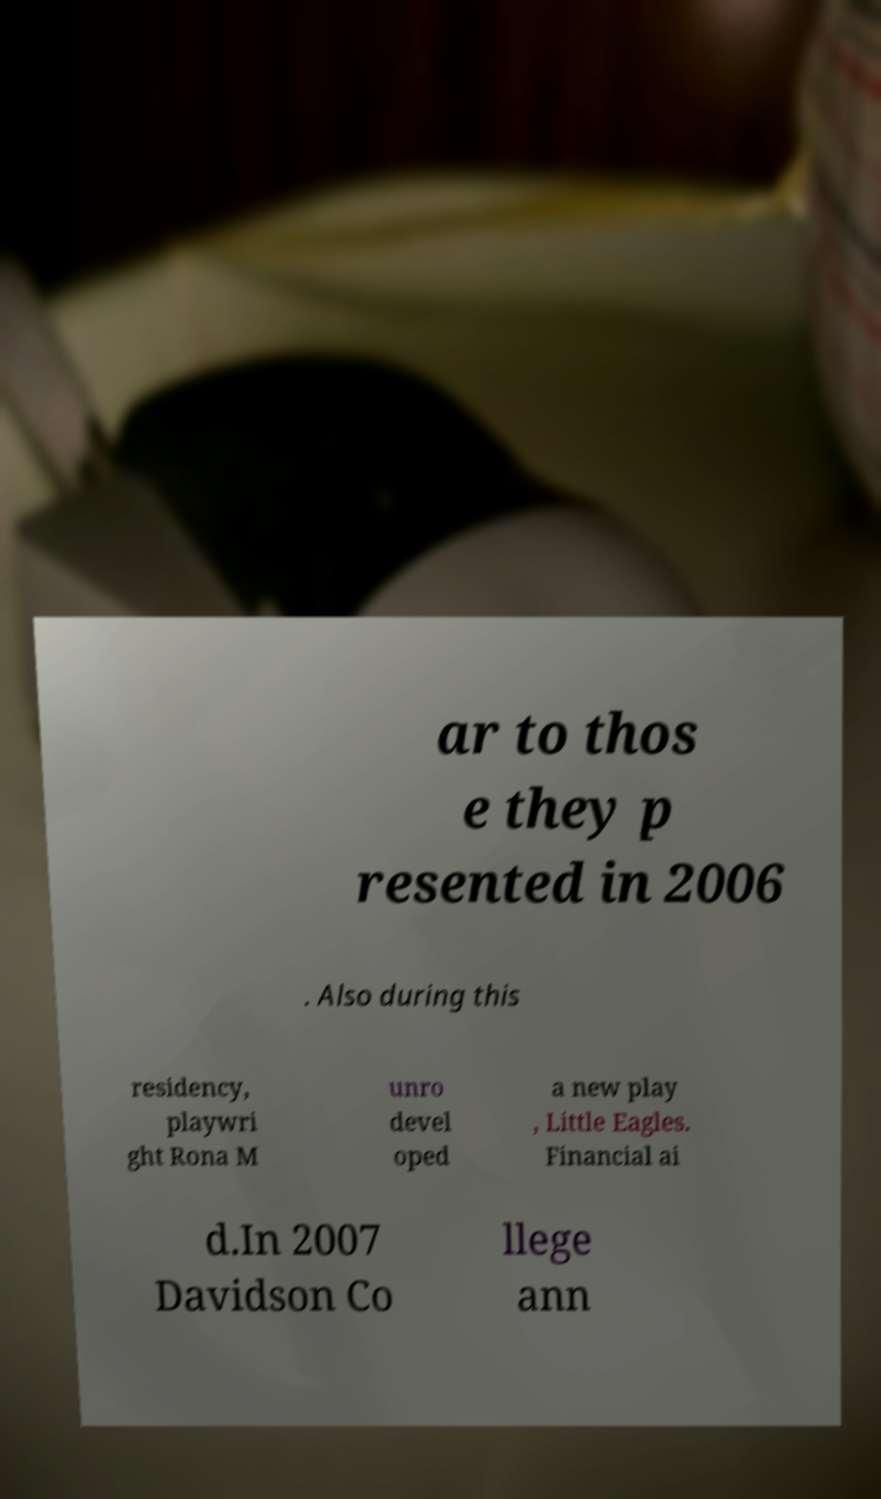Can you read and provide the text displayed in the image?This photo seems to have some interesting text. Can you extract and type it out for me? ar to thos e they p resented in 2006 . Also during this residency, playwri ght Rona M unro devel oped a new play , Little Eagles. Financial ai d.In 2007 Davidson Co llege ann 